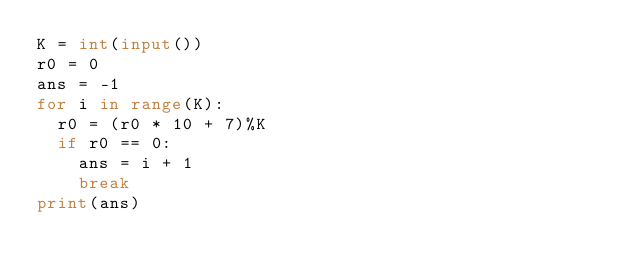Convert code to text. <code><loc_0><loc_0><loc_500><loc_500><_Python_>K = int(input())
r0 = 0
ans = -1
for i in range(K):
  r0 = (r0 * 10 + 7)%K
  if r0 == 0:
    ans = i + 1
    break    
print(ans)</code> 